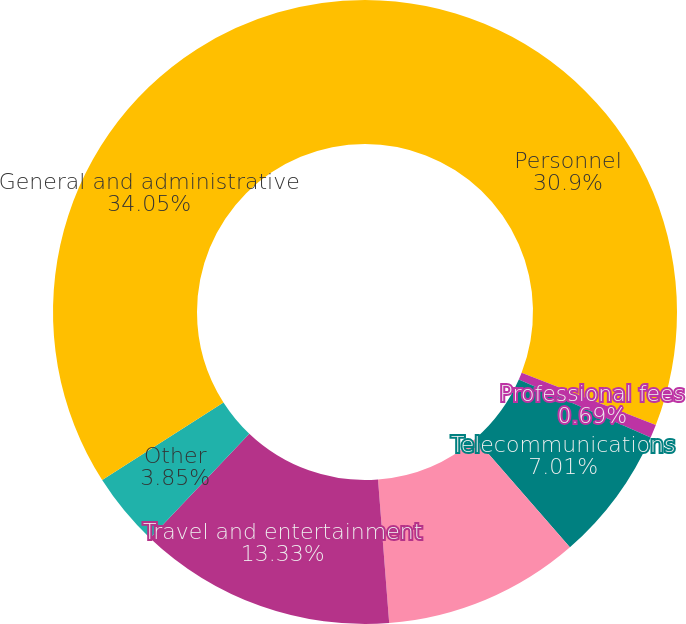Convert chart. <chart><loc_0><loc_0><loc_500><loc_500><pie_chart><fcel>Personnel<fcel>Professional fees<fcel>Telecommunications<fcel>Data processing<fcel>Travel and entertainment<fcel>Other<fcel>General and administrative<nl><fcel>30.9%<fcel>0.69%<fcel>7.01%<fcel>10.17%<fcel>13.33%<fcel>3.85%<fcel>34.06%<nl></chart> 